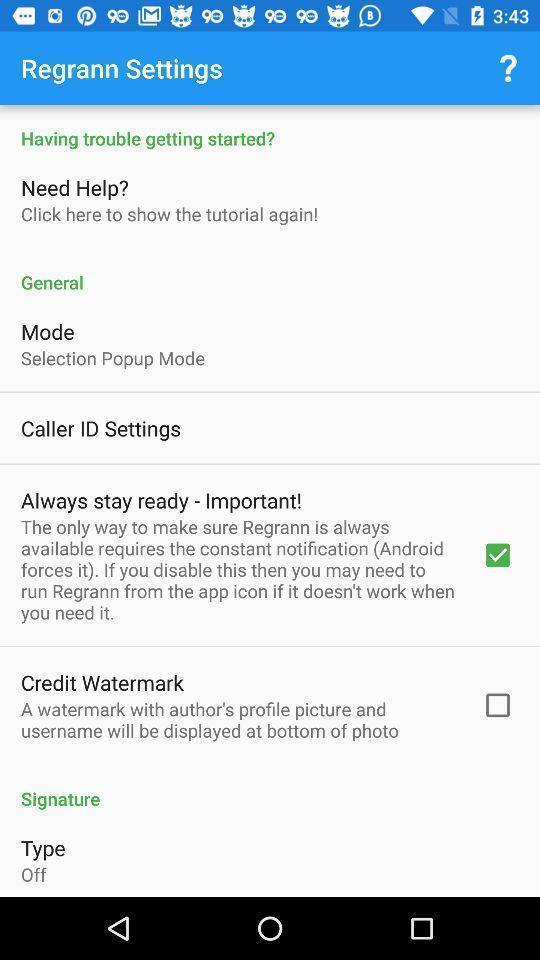Describe the key features of this screenshot. Page showing the various options in settings. 